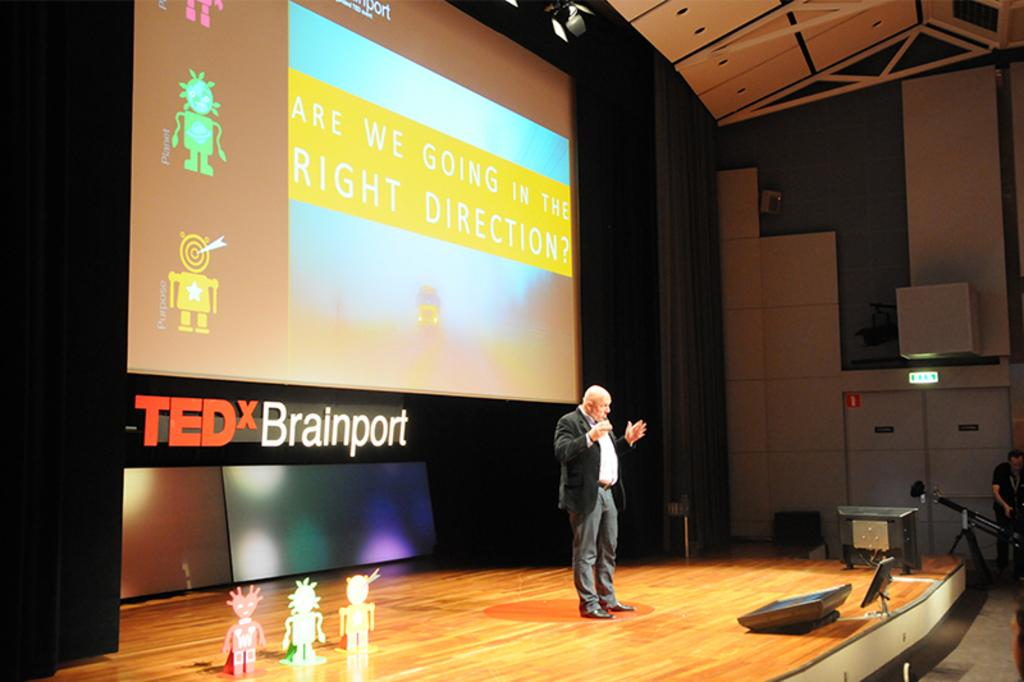<image>
Summarize the visual content of the image. A man is on a stage presenting at TEDx Brainport. 